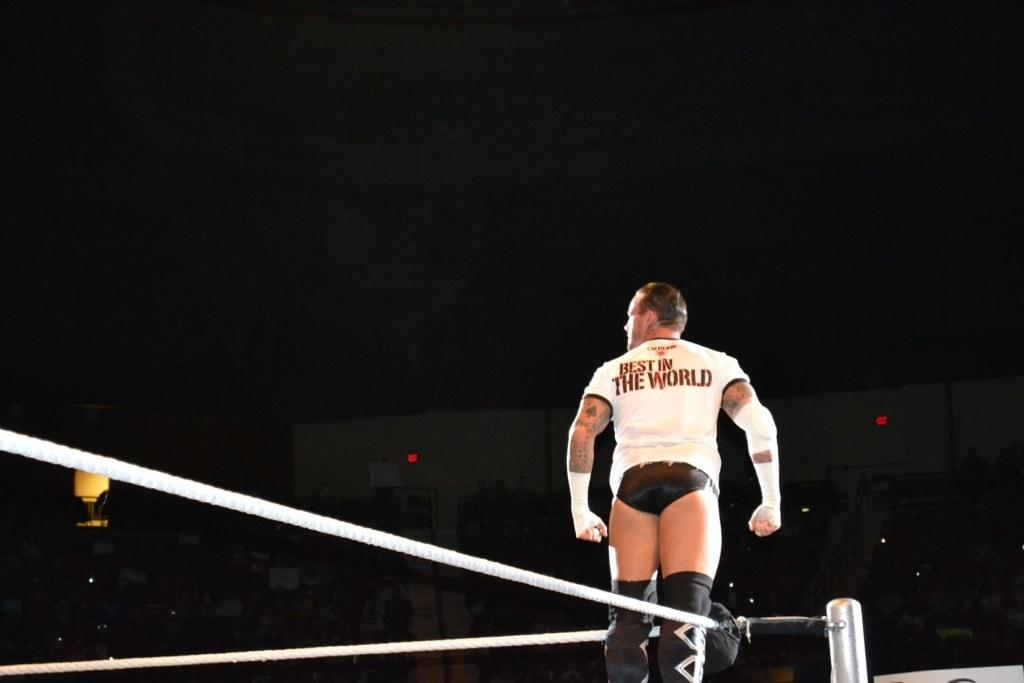<image>
Write a terse but informative summary of the picture. A man stands in a ring wearing a shirt that says, "Best in the World." 